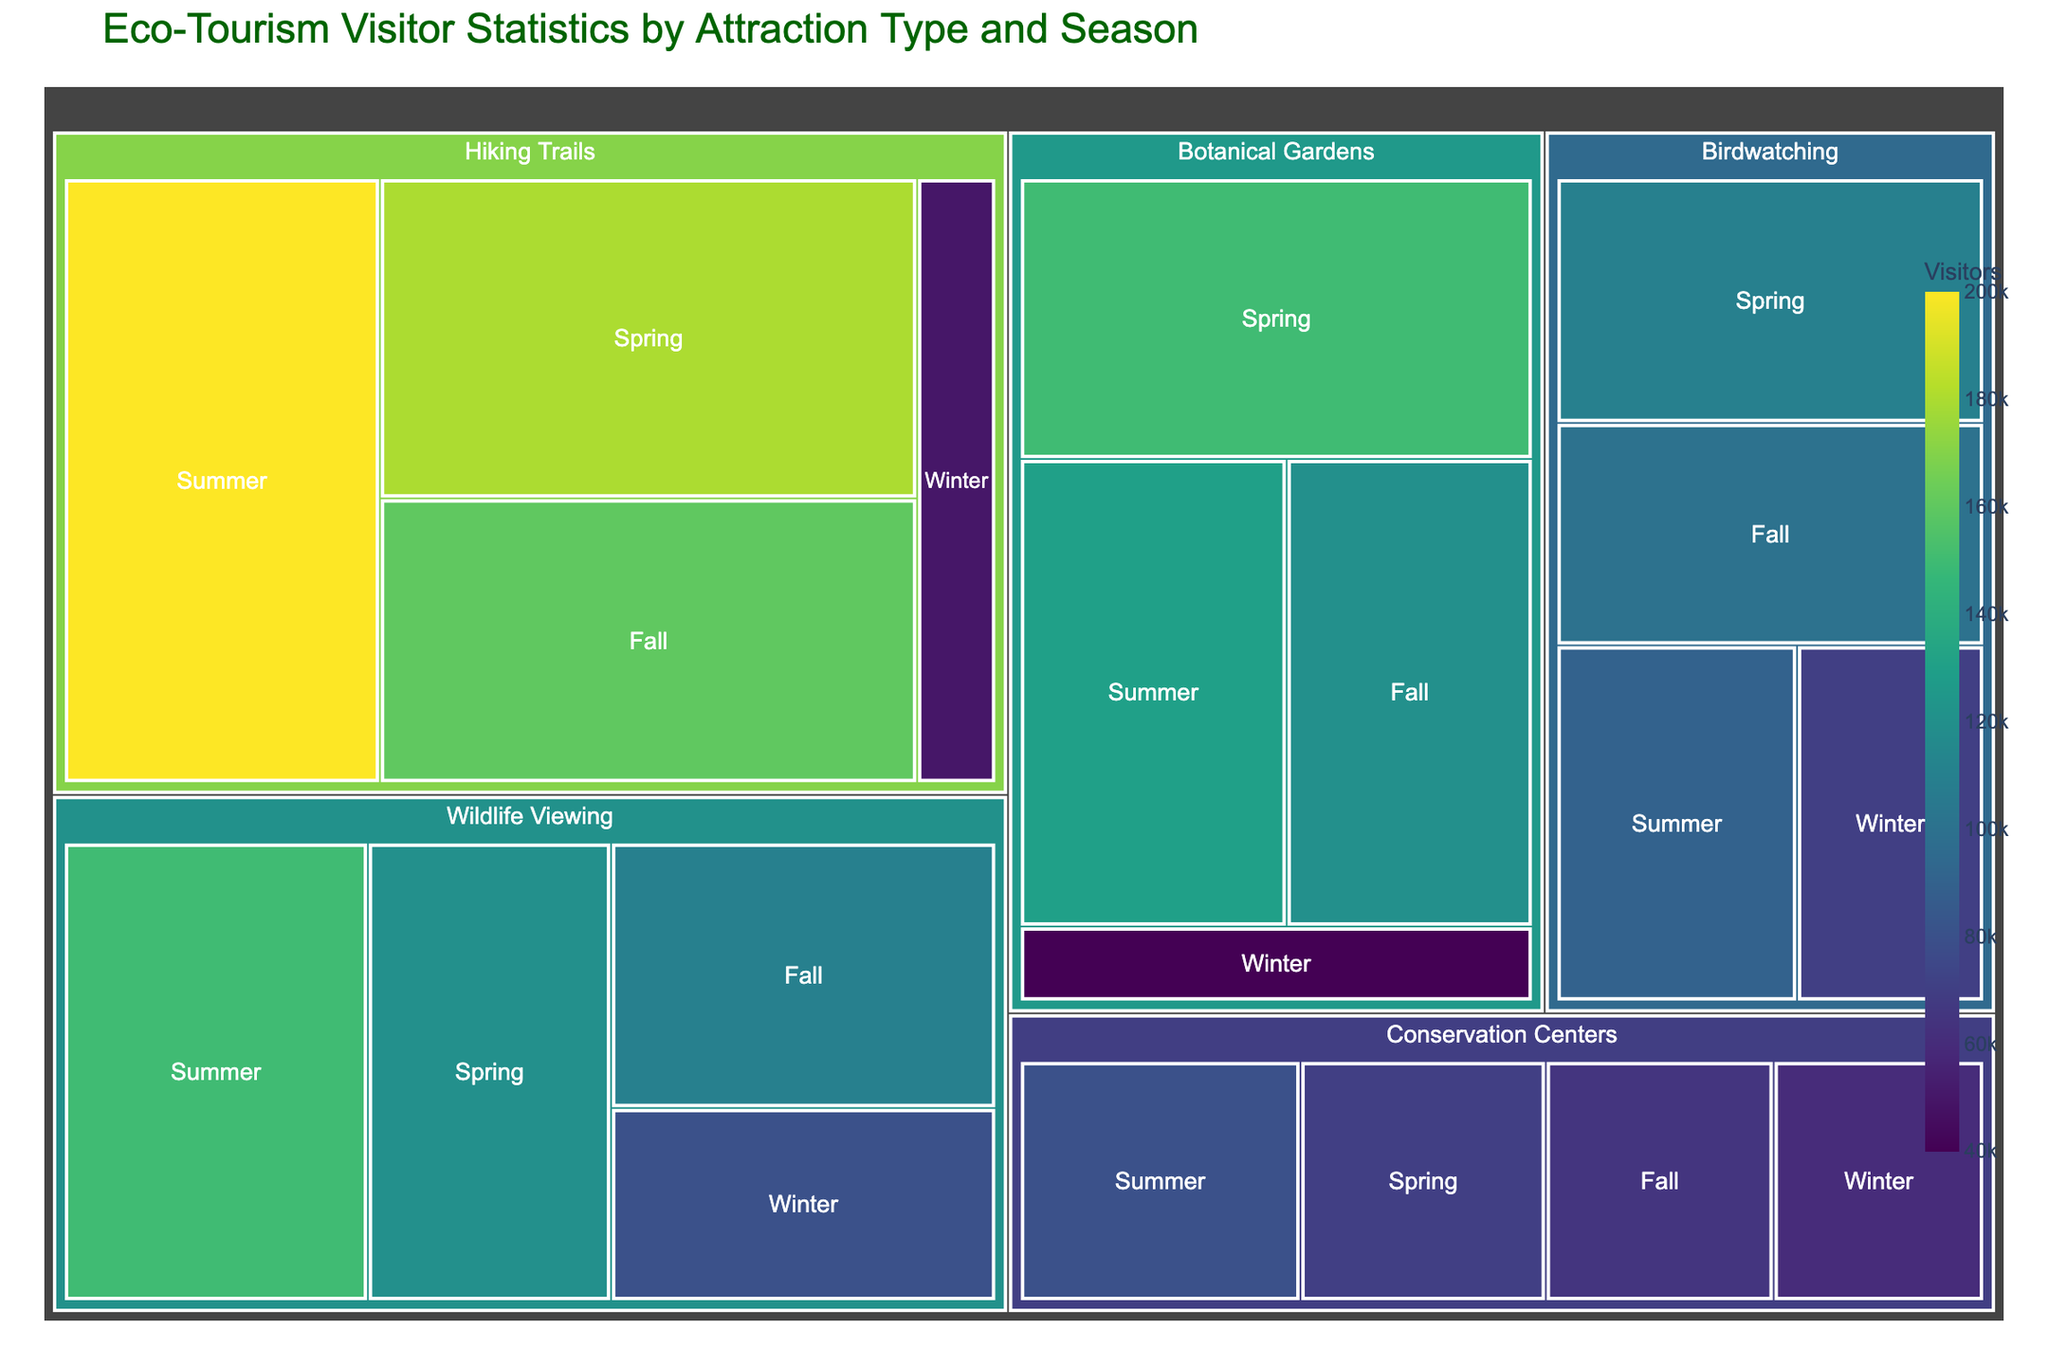Which attraction type has the highest number of visitors in summer? Refer to the summer segment of the treemap and identify which block representing attraction types has the largest area. The treemap shows that Hiking Trails has the largest block in summer.
Answer: Hiking Trails What is the difference in visitor numbers between Wildlife Viewing in summer and winter? Look at the blocks for Wildlife Viewing in summer (150,000 visitors) and winter (80,000 visitors), then calculate the difference: 150,000 - 80,000 = 70,000.
Answer: 70,000 Which season has the lowest number of visitors for Botanical Gardens? Examine the blocks for Botanical Gardens in each season. The winter block is the smallest, indicating it has the lowest number of visitors (40,000).
Answer: Winter Compare the total visitors for Birdwatching in spring and fall. Which is higher? Check the blocks for Birdwatching in spring (110,000 visitors) and fall (100,000 visitors). Spring has more visitors than fall.
Answer: Spring What is the average number of visitors for Conservation Centers across all seasons? Find the number of visitors for Conservation Centers in each season: Summer (80,000), Winter (60,000), Spring (70,000), Fall (65,000). The total is 80,000 + 60,000 + 70,000 + 65,000 = 275,000. There are 4 seasons, so the average is 275,000 / 4 = 68,750.
Answer: 68,750 How does the visitor count for Hiking Trails in fall compare with Botanical Gardens in the same season? Compare the blocks for Hiking Trails (160,000 visitors) and Botanical Gardens (120,000 visitors) in fall. Hiking Trails has more visitors.
Answer: Hiking Trails has more visitors Among the listed attraction types, which one has the least visitors in the winter? Identify the smallest block in winter among the attraction types. Botanical Gardens has 40,000 visitors, which is the smallest compared to others.
Answer: Botanical Gardens Which season sees the highest number of visitors for Birdwatching? Look at the blocks for Birdwatching across all seasons and find the one with the largest area. Birdwatching has the most visitors in spring (110,000).
Answer: Spring What is the combined number of visitors for Wildlife Viewing and Birdwatching in spring? Add the visitors for Wildlife Viewing (120,000) and Birdwatching (110,000) in spring: 120,000 + 110,000 = 230,000.
Answer: 230,000 If you combine the visitor numbers for all attraction types in fall, what is the total? Sum the visitors for each attraction type in fall: Wildlife Viewing (110,000) + Hiking Trails (160,000) + Birdwatching (100,000) + Botanical Gardens (120,000) + Conservation Centers (65,000) = 555,000.
Answer: 555,000 